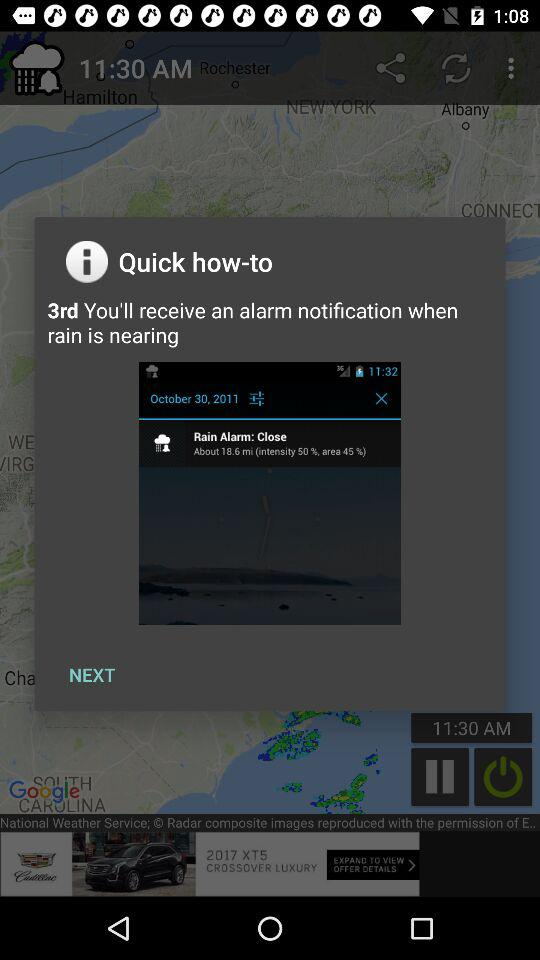What is the time? The time is 11:30 a.m. 